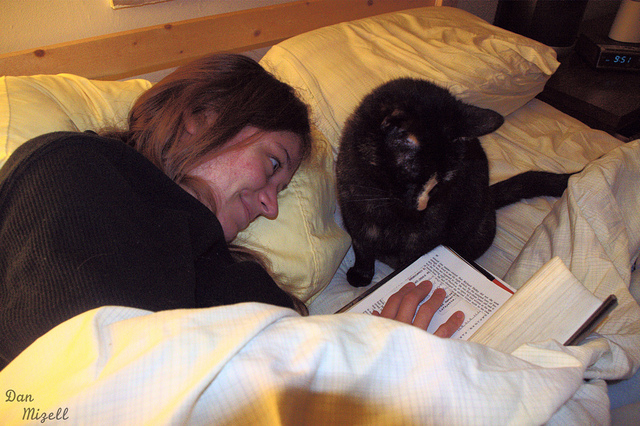<image>Is the dog small or large? The dog in the image could be small or large, but it might also be that there's no dog at all. Is the dog small or large? I don't know if the dog is small or large. It can be seen as small. 